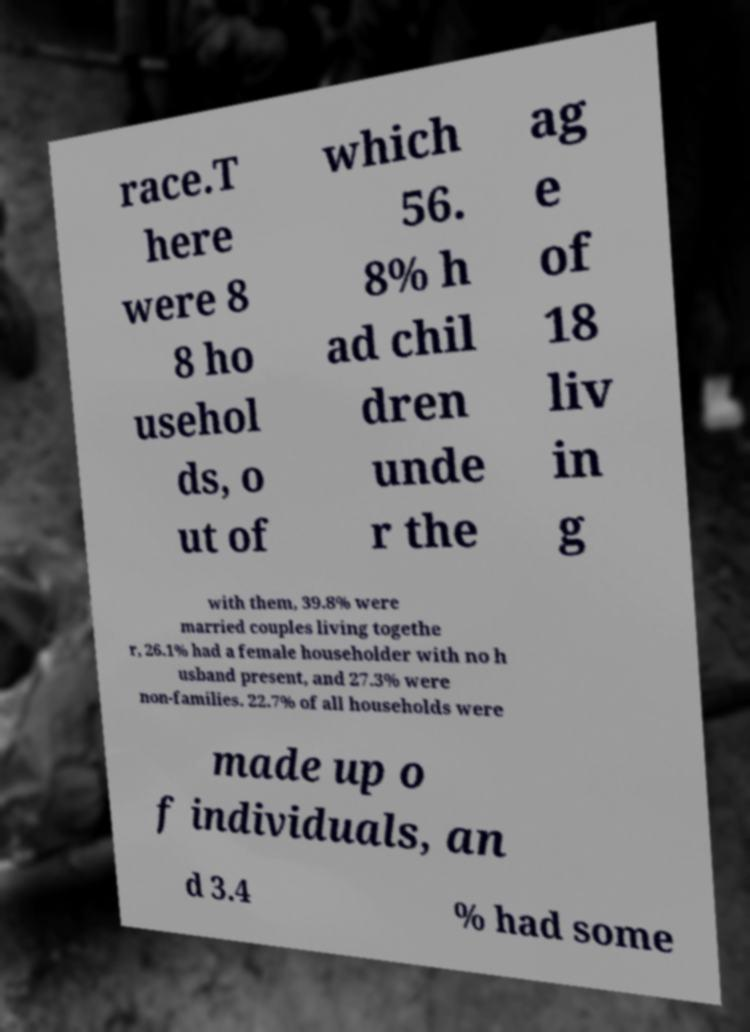Please identify and transcribe the text found in this image. race.T here were 8 8 ho usehol ds, o ut of which 56. 8% h ad chil dren unde r the ag e of 18 liv in g with them, 39.8% were married couples living togethe r, 26.1% had a female householder with no h usband present, and 27.3% were non-families. 22.7% of all households were made up o f individuals, an d 3.4 % had some 